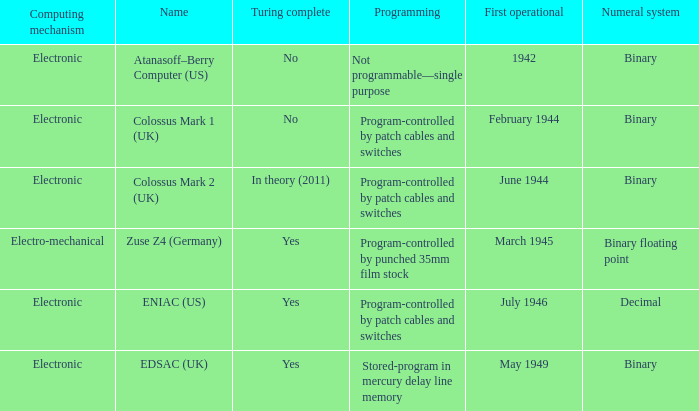Could you parse the entire table? {'header': ['Computing mechanism', 'Name', 'Turing complete', 'Programming', 'First operational', 'Numeral system'], 'rows': [['Electronic', 'Atanasoff–Berry Computer (US)', 'No', 'Not programmable—single purpose', '1942', 'Binary'], ['Electronic', 'Colossus Mark 1 (UK)', 'No', 'Program-controlled by patch cables and switches', 'February 1944', 'Binary'], ['Electronic', 'Colossus Mark 2 (UK)', 'In theory (2011)', 'Program-controlled by patch cables and switches', 'June 1944', 'Binary'], ['Electro-mechanical', 'Zuse Z4 (Germany)', 'Yes', 'Program-controlled by punched 35mm film stock', 'March 1945', 'Binary floating point'], ['Electronic', 'ENIAC (US)', 'Yes', 'Program-controlled by patch cables and switches', 'July 1946', 'Decimal'], ['Electronic', 'EDSAC (UK)', 'Yes', 'Stored-program in mercury delay line memory', 'May 1949', 'Binary']]} What's the computing mechanbeingm with name being atanasoff–berry computer (us) Electronic. 